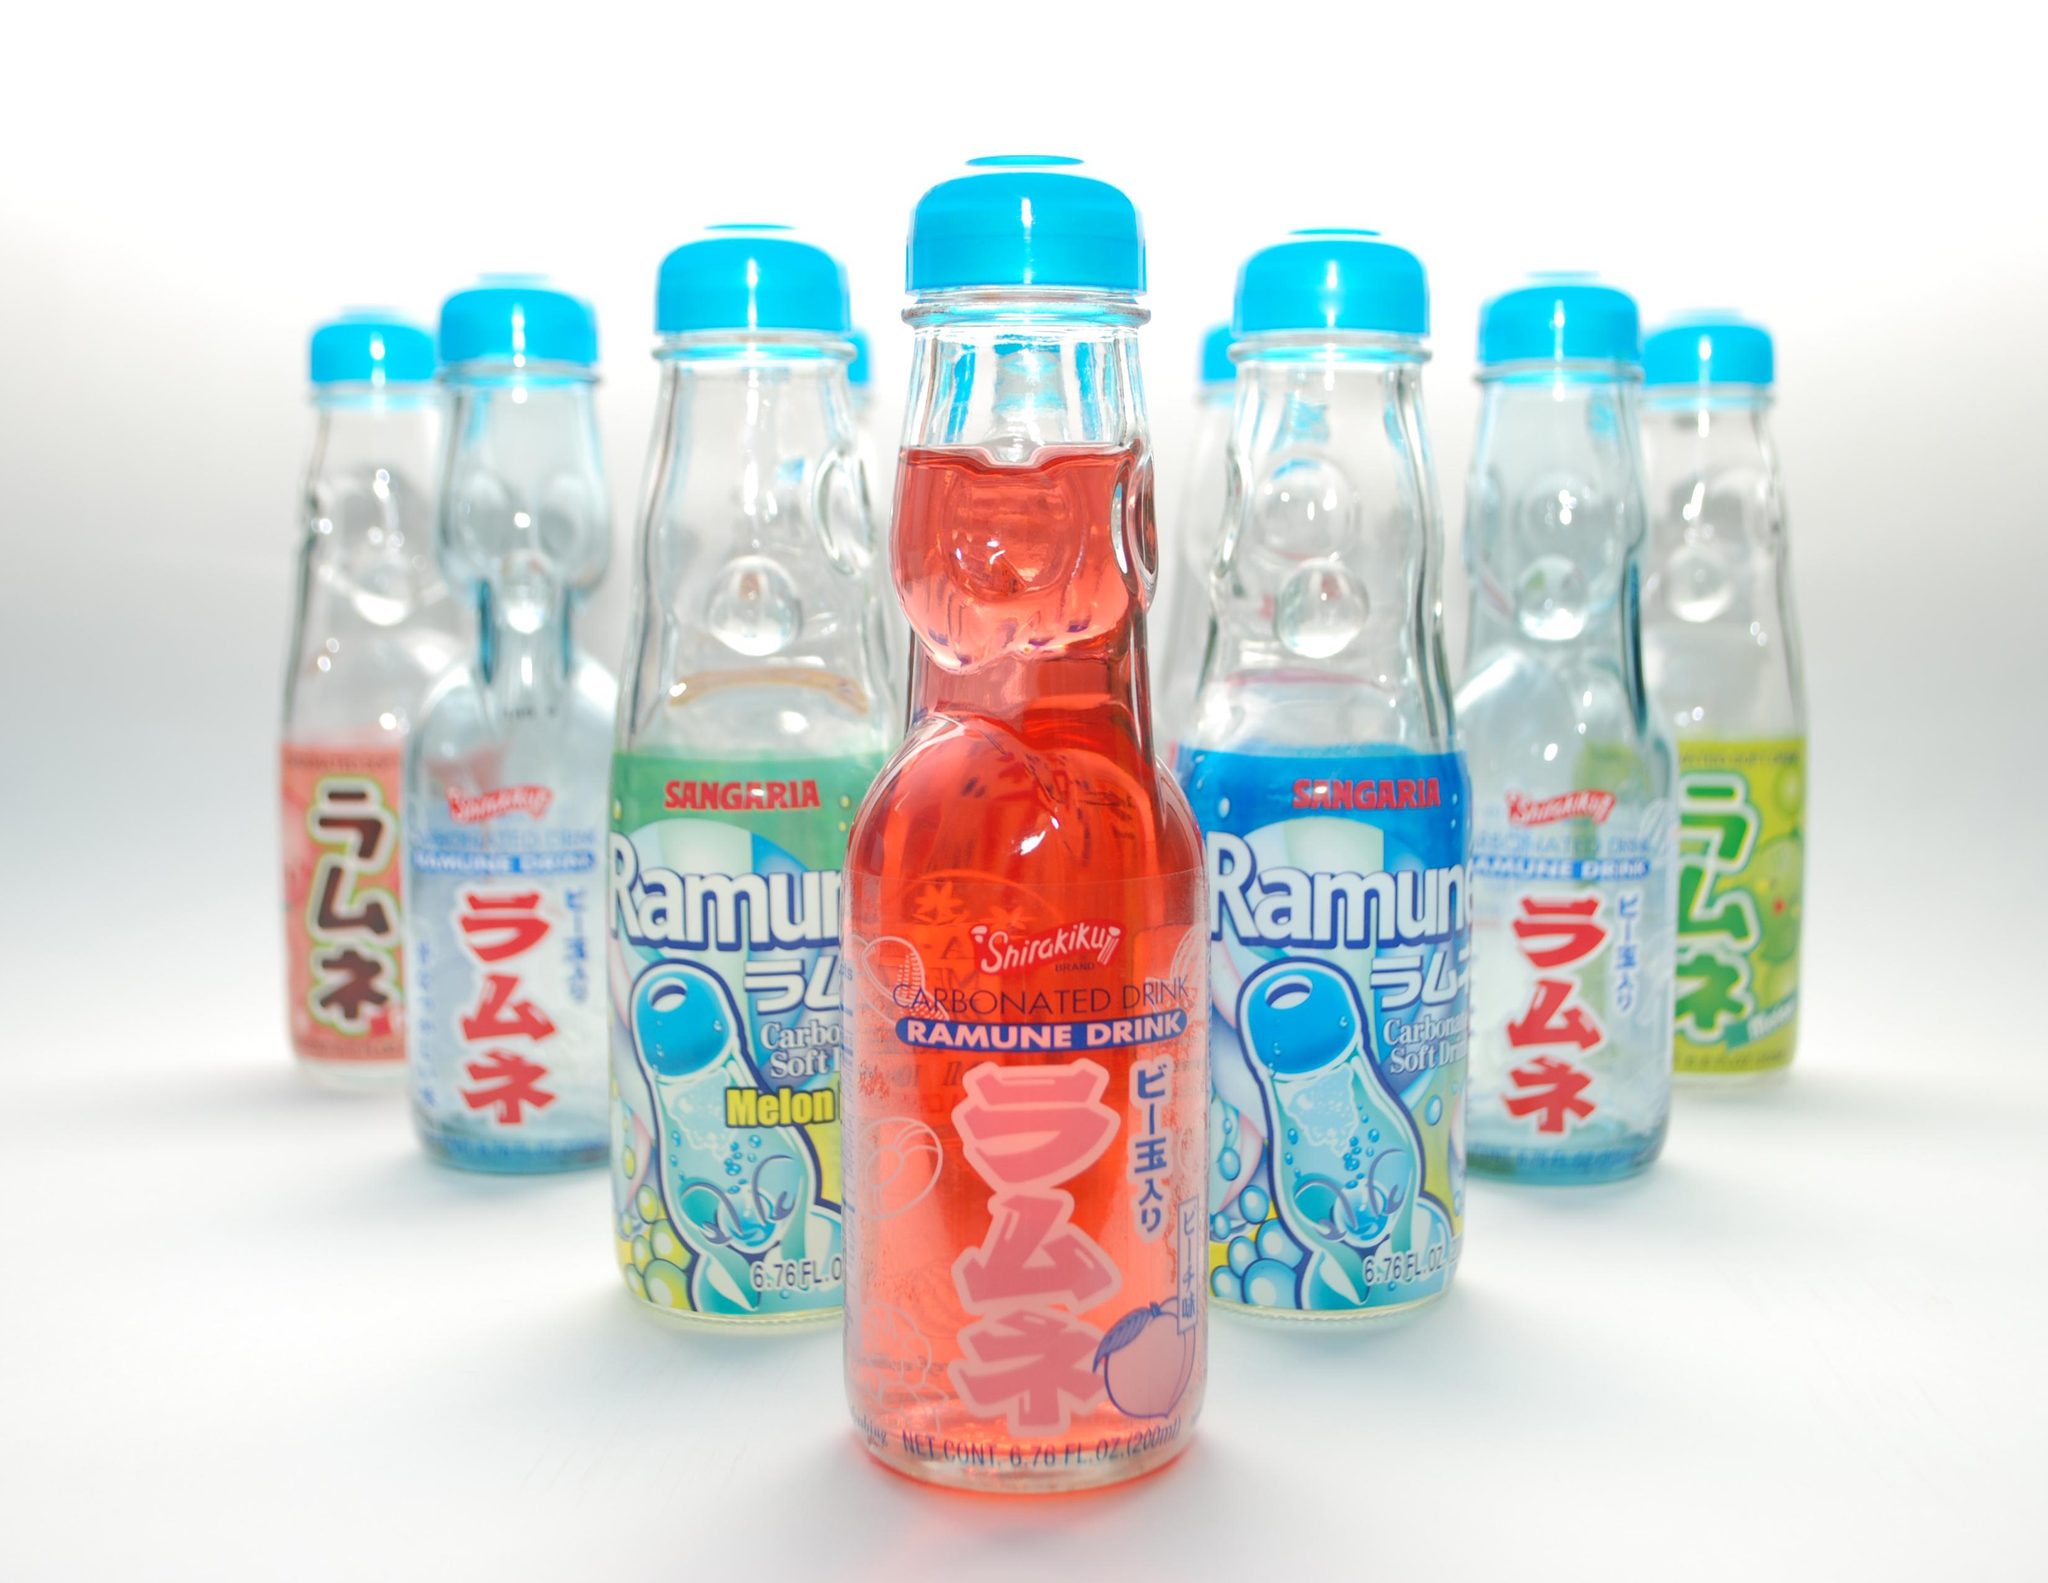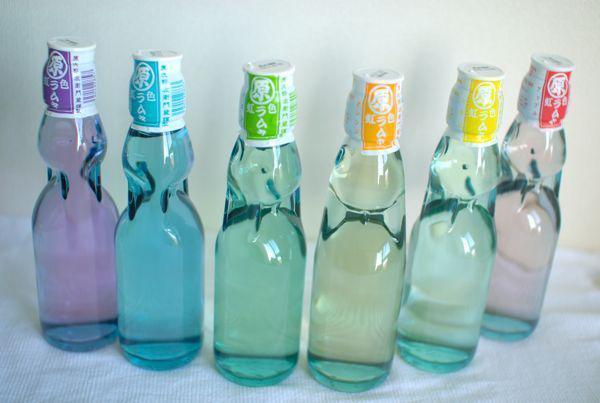The first image is the image on the left, the second image is the image on the right. For the images displayed, is the sentence "There are no more than three bottles in the right image." factually correct? Answer yes or no. No. The first image is the image on the left, the second image is the image on the right. Assess this claim about the two images: "One of the bottles is filled with red liquid.". Correct or not? Answer yes or no. Yes. 